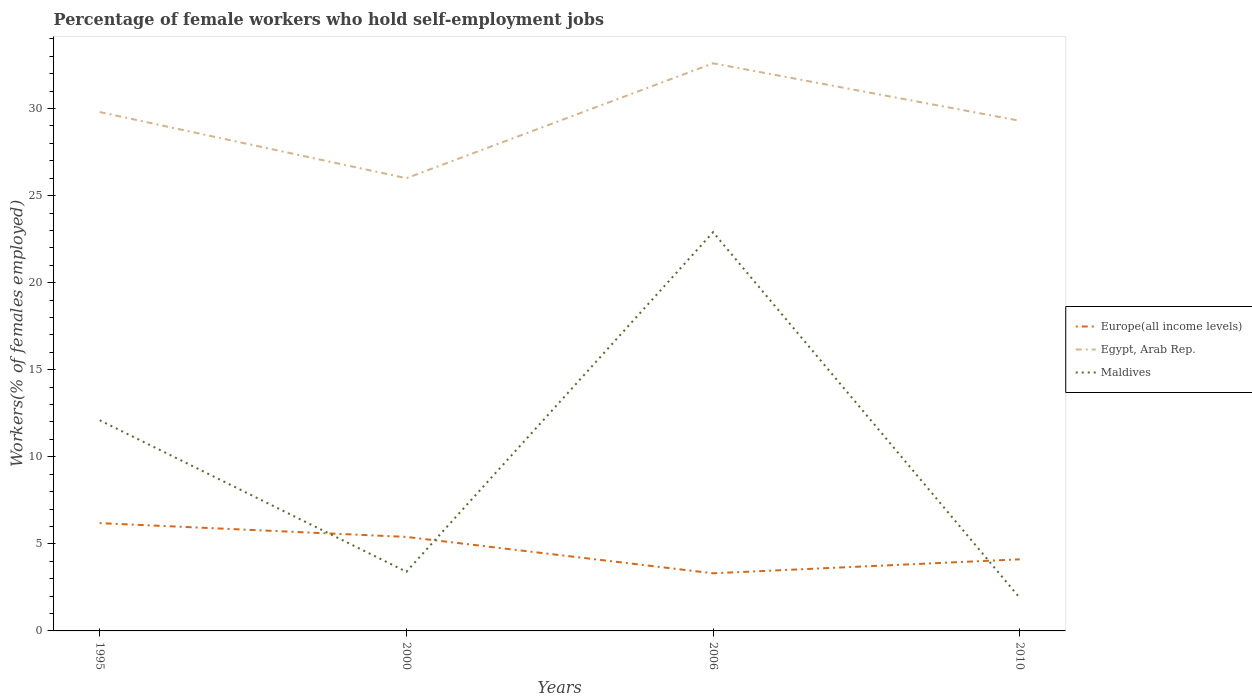Does the line corresponding to Maldives intersect with the line corresponding to Europe(all income levels)?
Offer a very short reply. Yes. Is the number of lines equal to the number of legend labels?
Provide a short and direct response. Yes. Across all years, what is the maximum percentage of self-employed female workers in Europe(all income levels)?
Your answer should be very brief. 3.31. What is the total percentage of self-employed female workers in Maldives in the graph?
Your response must be concise. -10.8. What is the difference between the highest and the second highest percentage of self-employed female workers in Egypt, Arab Rep.?
Your answer should be very brief. 6.6. What is the difference between the highest and the lowest percentage of self-employed female workers in Maldives?
Ensure brevity in your answer.  2. What is the difference between two consecutive major ticks on the Y-axis?
Provide a short and direct response. 5. Are the values on the major ticks of Y-axis written in scientific E-notation?
Offer a very short reply. No. Does the graph contain grids?
Offer a terse response. No. Where does the legend appear in the graph?
Give a very brief answer. Center right. What is the title of the graph?
Keep it short and to the point. Percentage of female workers who hold self-employment jobs. What is the label or title of the X-axis?
Your answer should be very brief. Years. What is the label or title of the Y-axis?
Your response must be concise. Workers(% of females employed). What is the Workers(% of females employed) of Europe(all income levels) in 1995?
Provide a succinct answer. 6.19. What is the Workers(% of females employed) of Egypt, Arab Rep. in 1995?
Make the answer very short. 29.8. What is the Workers(% of females employed) in Maldives in 1995?
Provide a short and direct response. 12.1. What is the Workers(% of females employed) in Europe(all income levels) in 2000?
Offer a terse response. 5.4. What is the Workers(% of females employed) of Maldives in 2000?
Provide a succinct answer. 3.4. What is the Workers(% of females employed) of Europe(all income levels) in 2006?
Provide a succinct answer. 3.31. What is the Workers(% of females employed) of Egypt, Arab Rep. in 2006?
Offer a very short reply. 32.6. What is the Workers(% of females employed) in Maldives in 2006?
Give a very brief answer. 22.9. What is the Workers(% of females employed) of Europe(all income levels) in 2010?
Make the answer very short. 4.11. What is the Workers(% of females employed) of Egypt, Arab Rep. in 2010?
Keep it short and to the point. 29.3. What is the Workers(% of females employed) of Maldives in 2010?
Offer a very short reply. 1.9. Across all years, what is the maximum Workers(% of females employed) in Europe(all income levels)?
Provide a succinct answer. 6.19. Across all years, what is the maximum Workers(% of females employed) of Egypt, Arab Rep.?
Offer a very short reply. 32.6. Across all years, what is the maximum Workers(% of females employed) in Maldives?
Your answer should be compact. 22.9. Across all years, what is the minimum Workers(% of females employed) in Europe(all income levels)?
Your response must be concise. 3.31. Across all years, what is the minimum Workers(% of females employed) in Maldives?
Offer a terse response. 1.9. What is the total Workers(% of females employed) of Europe(all income levels) in the graph?
Provide a succinct answer. 19.01. What is the total Workers(% of females employed) of Egypt, Arab Rep. in the graph?
Provide a short and direct response. 117.7. What is the total Workers(% of females employed) in Maldives in the graph?
Make the answer very short. 40.3. What is the difference between the Workers(% of females employed) in Europe(all income levels) in 1995 and that in 2000?
Provide a short and direct response. 0.79. What is the difference between the Workers(% of females employed) of Egypt, Arab Rep. in 1995 and that in 2000?
Ensure brevity in your answer.  3.8. What is the difference between the Workers(% of females employed) of Maldives in 1995 and that in 2000?
Provide a short and direct response. 8.7. What is the difference between the Workers(% of females employed) in Europe(all income levels) in 1995 and that in 2006?
Ensure brevity in your answer.  2.88. What is the difference between the Workers(% of females employed) of Maldives in 1995 and that in 2006?
Your response must be concise. -10.8. What is the difference between the Workers(% of females employed) of Europe(all income levels) in 1995 and that in 2010?
Provide a succinct answer. 2.08. What is the difference between the Workers(% of females employed) of Egypt, Arab Rep. in 1995 and that in 2010?
Keep it short and to the point. 0.5. What is the difference between the Workers(% of females employed) in Maldives in 1995 and that in 2010?
Make the answer very short. 10.2. What is the difference between the Workers(% of females employed) in Europe(all income levels) in 2000 and that in 2006?
Provide a short and direct response. 2.09. What is the difference between the Workers(% of females employed) in Egypt, Arab Rep. in 2000 and that in 2006?
Give a very brief answer. -6.6. What is the difference between the Workers(% of females employed) in Maldives in 2000 and that in 2006?
Keep it short and to the point. -19.5. What is the difference between the Workers(% of females employed) in Europe(all income levels) in 2000 and that in 2010?
Keep it short and to the point. 1.29. What is the difference between the Workers(% of females employed) in Europe(all income levels) in 2006 and that in 2010?
Your answer should be compact. -0.8. What is the difference between the Workers(% of females employed) of Europe(all income levels) in 1995 and the Workers(% of females employed) of Egypt, Arab Rep. in 2000?
Your answer should be compact. -19.81. What is the difference between the Workers(% of females employed) of Europe(all income levels) in 1995 and the Workers(% of females employed) of Maldives in 2000?
Your answer should be compact. 2.79. What is the difference between the Workers(% of females employed) of Egypt, Arab Rep. in 1995 and the Workers(% of females employed) of Maldives in 2000?
Make the answer very short. 26.4. What is the difference between the Workers(% of females employed) of Europe(all income levels) in 1995 and the Workers(% of females employed) of Egypt, Arab Rep. in 2006?
Your answer should be very brief. -26.41. What is the difference between the Workers(% of females employed) of Europe(all income levels) in 1995 and the Workers(% of females employed) of Maldives in 2006?
Give a very brief answer. -16.71. What is the difference between the Workers(% of females employed) in Egypt, Arab Rep. in 1995 and the Workers(% of females employed) in Maldives in 2006?
Provide a short and direct response. 6.9. What is the difference between the Workers(% of females employed) of Europe(all income levels) in 1995 and the Workers(% of females employed) of Egypt, Arab Rep. in 2010?
Make the answer very short. -23.11. What is the difference between the Workers(% of females employed) in Europe(all income levels) in 1995 and the Workers(% of females employed) in Maldives in 2010?
Ensure brevity in your answer.  4.29. What is the difference between the Workers(% of females employed) in Egypt, Arab Rep. in 1995 and the Workers(% of females employed) in Maldives in 2010?
Offer a terse response. 27.9. What is the difference between the Workers(% of females employed) in Europe(all income levels) in 2000 and the Workers(% of females employed) in Egypt, Arab Rep. in 2006?
Provide a succinct answer. -27.2. What is the difference between the Workers(% of females employed) in Europe(all income levels) in 2000 and the Workers(% of females employed) in Maldives in 2006?
Your answer should be compact. -17.5. What is the difference between the Workers(% of females employed) in Europe(all income levels) in 2000 and the Workers(% of females employed) in Egypt, Arab Rep. in 2010?
Offer a terse response. -23.9. What is the difference between the Workers(% of females employed) in Europe(all income levels) in 2000 and the Workers(% of females employed) in Maldives in 2010?
Ensure brevity in your answer.  3.5. What is the difference between the Workers(% of females employed) in Egypt, Arab Rep. in 2000 and the Workers(% of females employed) in Maldives in 2010?
Ensure brevity in your answer.  24.1. What is the difference between the Workers(% of females employed) in Europe(all income levels) in 2006 and the Workers(% of females employed) in Egypt, Arab Rep. in 2010?
Your response must be concise. -25.99. What is the difference between the Workers(% of females employed) of Europe(all income levels) in 2006 and the Workers(% of females employed) of Maldives in 2010?
Provide a succinct answer. 1.41. What is the difference between the Workers(% of females employed) of Egypt, Arab Rep. in 2006 and the Workers(% of females employed) of Maldives in 2010?
Ensure brevity in your answer.  30.7. What is the average Workers(% of females employed) in Europe(all income levels) per year?
Provide a short and direct response. 4.75. What is the average Workers(% of females employed) in Egypt, Arab Rep. per year?
Offer a very short reply. 29.43. What is the average Workers(% of females employed) of Maldives per year?
Provide a succinct answer. 10.07. In the year 1995, what is the difference between the Workers(% of females employed) in Europe(all income levels) and Workers(% of females employed) in Egypt, Arab Rep.?
Provide a succinct answer. -23.61. In the year 1995, what is the difference between the Workers(% of females employed) of Europe(all income levels) and Workers(% of females employed) of Maldives?
Provide a short and direct response. -5.91. In the year 2000, what is the difference between the Workers(% of females employed) of Europe(all income levels) and Workers(% of females employed) of Egypt, Arab Rep.?
Your response must be concise. -20.6. In the year 2000, what is the difference between the Workers(% of females employed) of Europe(all income levels) and Workers(% of females employed) of Maldives?
Offer a terse response. 2. In the year 2000, what is the difference between the Workers(% of females employed) of Egypt, Arab Rep. and Workers(% of females employed) of Maldives?
Offer a terse response. 22.6. In the year 2006, what is the difference between the Workers(% of females employed) of Europe(all income levels) and Workers(% of females employed) of Egypt, Arab Rep.?
Your answer should be compact. -29.29. In the year 2006, what is the difference between the Workers(% of females employed) of Europe(all income levels) and Workers(% of females employed) of Maldives?
Provide a succinct answer. -19.59. In the year 2010, what is the difference between the Workers(% of females employed) in Europe(all income levels) and Workers(% of females employed) in Egypt, Arab Rep.?
Offer a terse response. -25.19. In the year 2010, what is the difference between the Workers(% of females employed) of Europe(all income levels) and Workers(% of females employed) of Maldives?
Your response must be concise. 2.21. In the year 2010, what is the difference between the Workers(% of females employed) in Egypt, Arab Rep. and Workers(% of females employed) in Maldives?
Offer a very short reply. 27.4. What is the ratio of the Workers(% of females employed) in Europe(all income levels) in 1995 to that in 2000?
Give a very brief answer. 1.15. What is the ratio of the Workers(% of females employed) of Egypt, Arab Rep. in 1995 to that in 2000?
Provide a short and direct response. 1.15. What is the ratio of the Workers(% of females employed) in Maldives in 1995 to that in 2000?
Provide a short and direct response. 3.56. What is the ratio of the Workers(% of females employed) in Europe(all income levels) in 1995 to that in 2006?
Ensure brevity in your answer.  1.87. What is the ratio of the Workers(% of females employed) of Egypt, Arab Rep. in 1995 to that in 2006?
Provide a succinct answer. 0.91. What is the ratio of the Workers(% of females employed) in Maldives in 1995 to that in 2006?
Make the answer very short. 0.53. What is the ratio of the Workers(% of females employed) of Europe(all income levels) in 1995 to that in 2010?
Offer a very short reply. 1.51. What is the ratio of the Workers(% of females employed) of Egypt, Arab Rep. in 1995 to that in 2010?
Keep it short and to the point. 1.02. What is the ratio of the Workers(% of females employed) in Maldives in 1995 to that in 2010?
Your response must be concise. 6.37. What is the ratio of the Workers(% of females employed) of Europe(all income levels) in 2000 to that in 2006?
Provide a short and direct response. 1.63. What is the ratio of the Workers(% of females employed) in Egypt, Arab Rep. in 2000 to that in 2006?
Ensure brevity in your answer.  0.8. What is the ratio of the Workers(% of females employed) in Maldives in 2000 to that in 2006?
Ensure brevity in your answer.  0.15. What is the ratio of the Workers(% of females employed) of Europe(all income levels) in 2000 to that in 2010?
Provide a short and direct response. 1.31. What is the ratio of the Workers(% of females employed) in Egypt, Arab Rep. in 2000 to that in 2010?
Make the answer very short. 0.89. What is the ratio of the Workers(% of females employed) in Maldives in 2000 to that in 2010?
Keep it short and to the point. 1.79. What is the ratio of the Workers(% of females employed) of Europe(all income levels) in 2006 to that in 2010?
Your response must be concise. 0.81. What is the ratio of the Workers(% of females employed) in Egypt, Arab Rep. in 2006 to that in 2010?
Provide a short and direct response. 1.11. What is the ratio of the Workers(% of females employed) of Maldives in 2006 to that in 2010?
Offer a terse response. 12.05. What is the difference between the highest and the second highest Workers(% of females employed) of Europe(all income levels)?
Make the answer very short. 0.79. What is the difference between the highest and the lowest Workers(% of females employed) of Europe(all income levels)?
Your response must be concise. 2.88. What is the difference between the highest and the lowest Workers(% of females employed) in Maldives?
Ensure brevity in your answer.  21. 